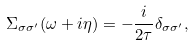<formula> <loc_0><loc_0><loc_500><loc_500>\Sigma _ { \sigma \sigma ^ { \prime } } ( \omega + i \eta ) = - \frac { i } { 2 \tau } \delta _ { \sigma \sigma ^ { \prime } } ,</formula> 